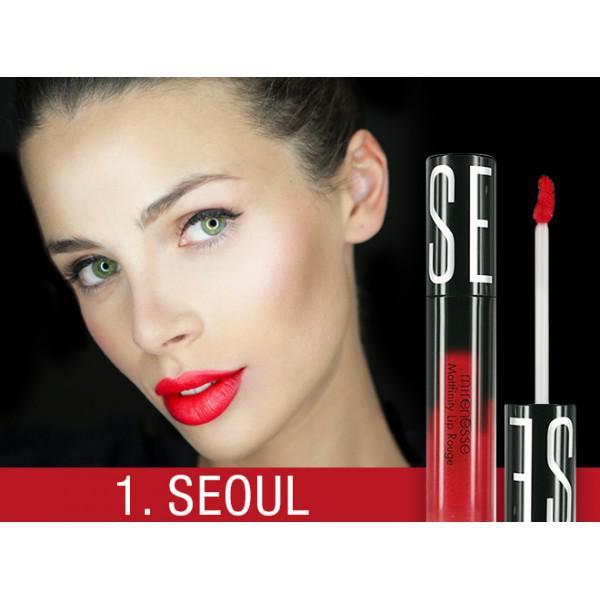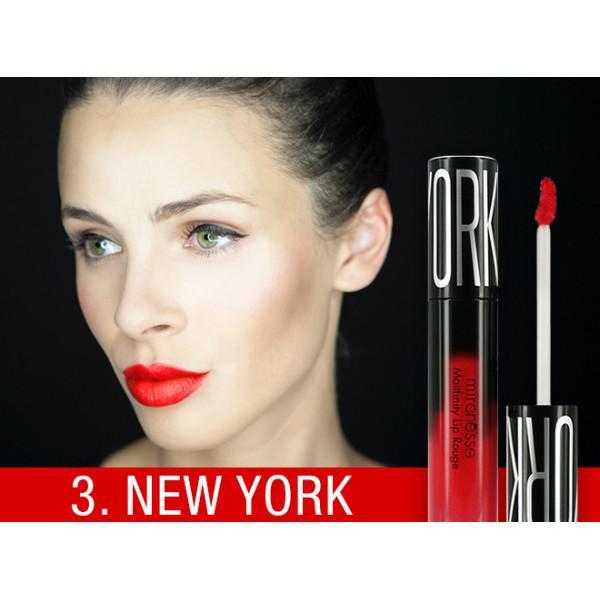The first image is the image on the left, the second image is the image on the right. Evaluate the accuracy of this statement regarding the images: "The woman's lips are closed in the image on the right.". Is it true? Answer yes or no. Yes. The first image is the image on the left, the second image is the image on the right. Analyze the images presented: Is the assertion "One image shows a model with tinted lips that are closed, so no teeth show." valid? Answer yes or no. Yes. 